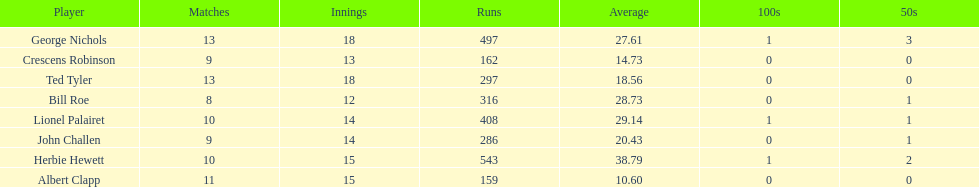What were the number of innings albert clapp had? 15. 